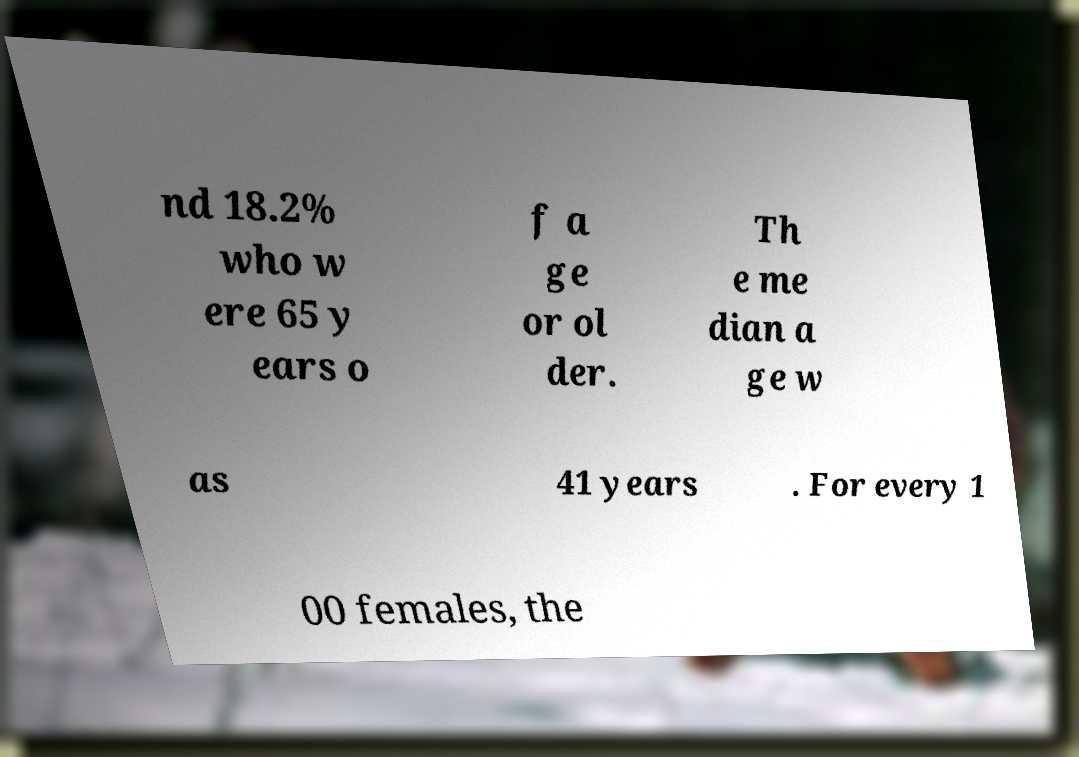Can you accurately transcribe the text from the provided image for me? nd 18.2% who w ere 65 y ears o f a ge or ol der. Th e me dian a ge w as 41 years . For every 1 00 females, the 